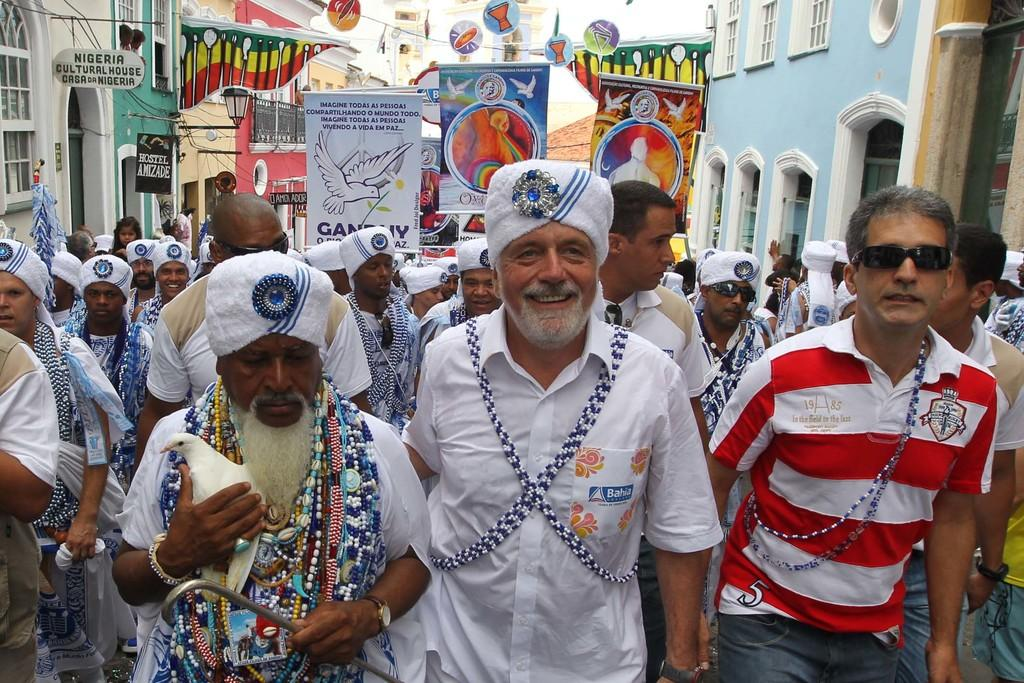What are the people in the image doing? The people in the image are walking. What are the people wearing on their heads? The people are wearing white color caps. What are the people holding in their hands? The people are holding banners. What can be seen on both sides of the image? There are buildings on both sides of the image. What type of signage is present in the image? There are boards with some text in the image. What type of spy equipment can be seen in the image? There is no spy equipment present in the image. What religious belief do the people in the image follow? There is no information about the people's religious beliefs in the image. 